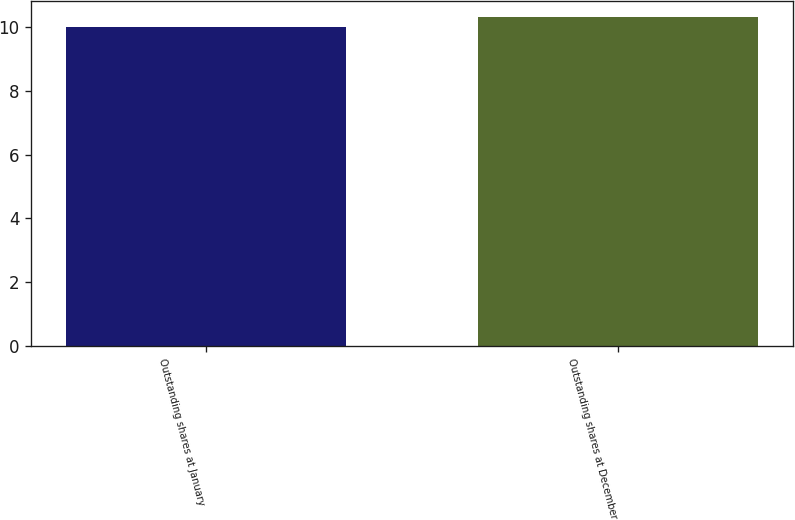<chart> <loc_0><loc_0><loc_500><loc_500><bar_chart><fcel>Outstanding shares at January<fcel>Outstanding shares at December<nl><fcel>10<fcel>10.3<nl></chart> 